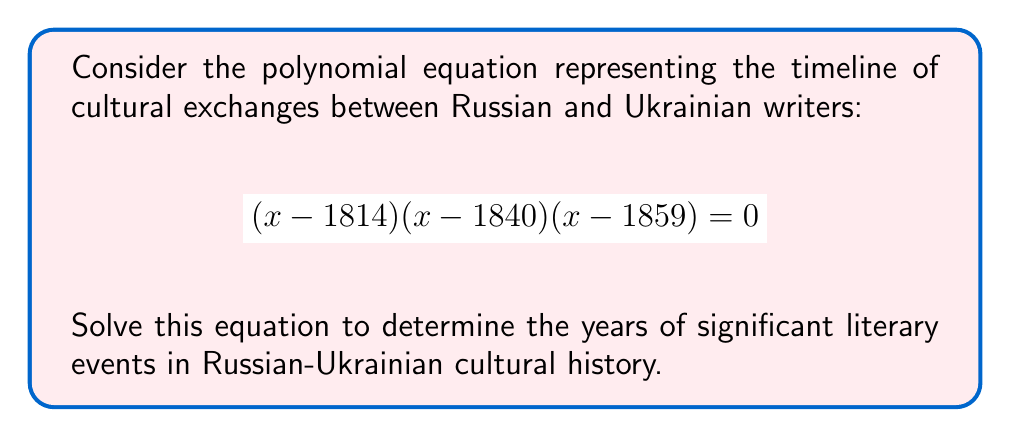Show me your answer to this math problem. To solve this polynomial equation, we need to find the roots of the polynomial. The equation is already factored, so we can use the zero product property:

1) The zero product property states that if the product of factors is zero, then at least one of the factors must be zero.

2) We have three factors:
   $(x - 1814) = 0$
   $(x - 1840) = 0$
   $(x - 1859) = 0$

3) Solving each factor:
   $x - 1814 = 0$, so $x = 1814$
   $x - 1840 = 0$, so $x = 1840$
   $x - 1859 = 0$, so $x = 1859$

4) These solutions represent significant years in Russian-Ukrainian literary history:
   - 1814: Birth of Taras Shevchenko, a prominent Ukrainian poet and artist
   - 1840: Publication of Mikhail Lermontov's "A Hero of Our Time", a pivotal Russian novel
   - 1859: Ivan Goncharov's "Oblomov" is published, a classic of Russian literature

These years mark important moments in the cultural exchange and development of Russian and Ukrainian literature.
Answer: $x = 1814, 1840, 1859$ 